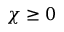<formula> <loc_0><loc_0><loc_500><loc_500>\chi \geq 0</formula> 